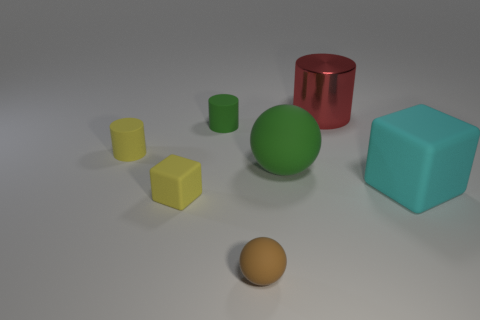Are there any blocks in front of the large cyan object?
Keep it short and to the point. Yes. There is a cylinder right of the tiny rubber object that is in front of the yellow rubber block; what is its material?
Your answer should be very brief. Metal. The other object that is the same shape as the small brown rubber object is what size?
Keep it short and to the point. Large. What is the color of the object that is both to the left of the large red shiny cylinder and on the right side of the brown matte thing?
Ensure brevity in your answer.  Green. Do the matte ball that is to the right of the brown ball and the large cyan rubber thing have the same size?
Offer a terse response. Yes. Are there any other things that have the same shape as the cyan thing?
Your response must be concise. Yes. Is the material of the big green object the same as the sphere on the left side of the big green matte thing?
Keep it short and to the point. Yes. What number of gray things are either big shiny objects or large objects?
Offer a terse response. 0. Are there any small cyan cylinders?
Ensure brevity in your answer.  No. There is a large block that is on the right side of the yellow object in front of the cyan rubber block; is there a cylinder that is to the left of it?
Give a very brief answer. Yes. 